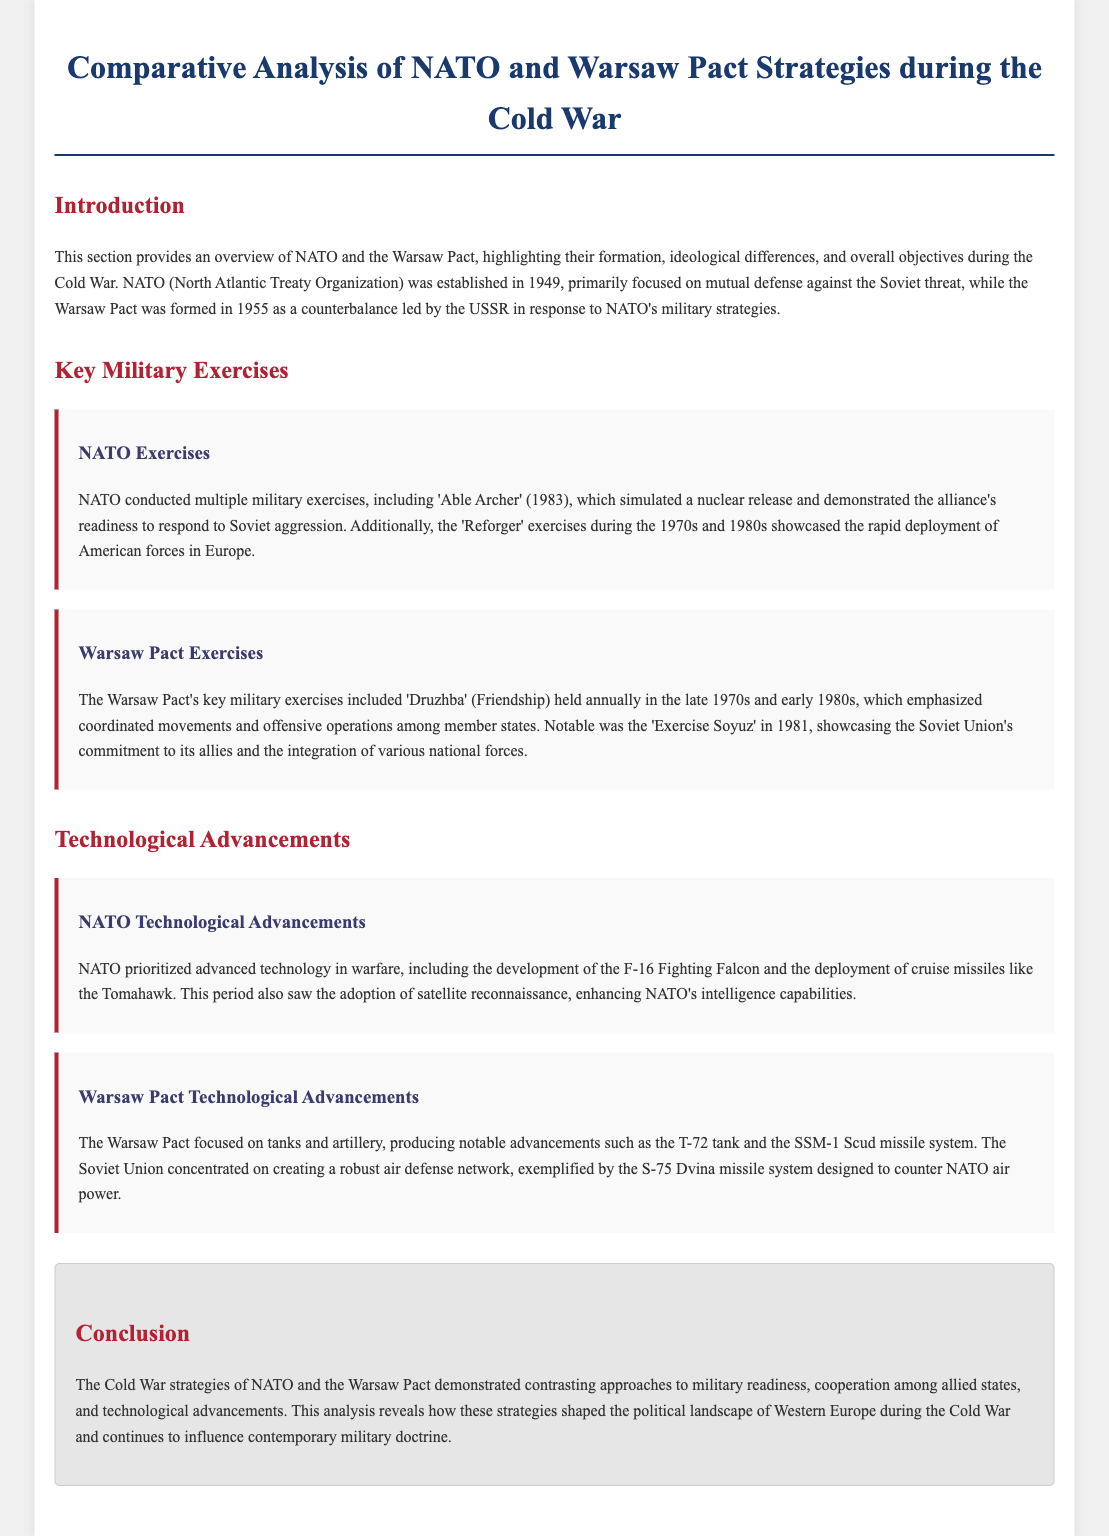What year was NATO established? NATO was established in 1949 as mentioned in the Introduction section.
Answer: 1949 What was the name of the Soviet tank developed under the Warsaw Pact? The document mentions the T-72 tank as a notable advancement produced by the Warsaw Pact.
Answer: T-72 What was the primary focus of NATO during the Cold War? The introduction states NATO was primarily focused on mutual defense against the Soviet threat.
Answer: Mutual defense Which NATO exercise simulated a nuclear release in 1983? The document mentions 'Able Archer' as the exercise that simulated a nuclear release.
Answer: Able Archer What was the main objective of the Warsaw Pact's 'Druzhba' exercises? 'Druzhba' emphasized coordinated movements and offensive operations among member states.
Answer: Coordinated movements How many key military exercises are highlighted for NATO in the document? The document highlights two key military exercises for NATO: 'Able Archer' and 'Reforger'.
Answer: Two What system did the Soviet Union develop to counter NATO air power? The S-75 Dvina missile system was developed by the Soviet Union for air defense.
Answer: S-75 Dvina What type of technology did NATO emphasize during the Cold War? NATO prioritized advanced technology in warfare, as mentioned under the Technological Advancements section.
Answer: Advanced technology How did the strategies of NATO and the Warsaw Pact differ according to the conclusion? The conclusion states that NATO and the Warsaw Pact demonstrated contrasting approaches.
Answer: Contrasting approaches 